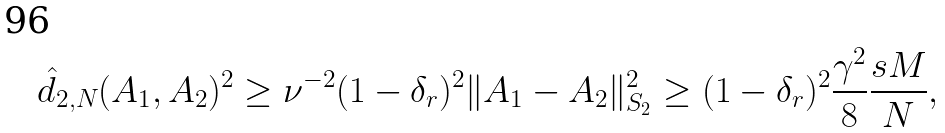<formula> <loc_0><loc_0><loc_500><loc_500>\hat { d } _ { 2 , N } ( A _ { 1 } , A _ { 2 } ) ^ { 2 } \geq \nu ^ { - 2 } ( 1 - \delta _ { r } ) ^ { 2 } \| A _ { 1 } - A _ { 2 } \| _ { S _ { 2 } } ^ { 2 } \geq ( 1 - \delta _ { r } ) ^ { 2 } \frac { \gamma ^ { 2 } } { 8 } \frac { s M } { N } ,</formula> 